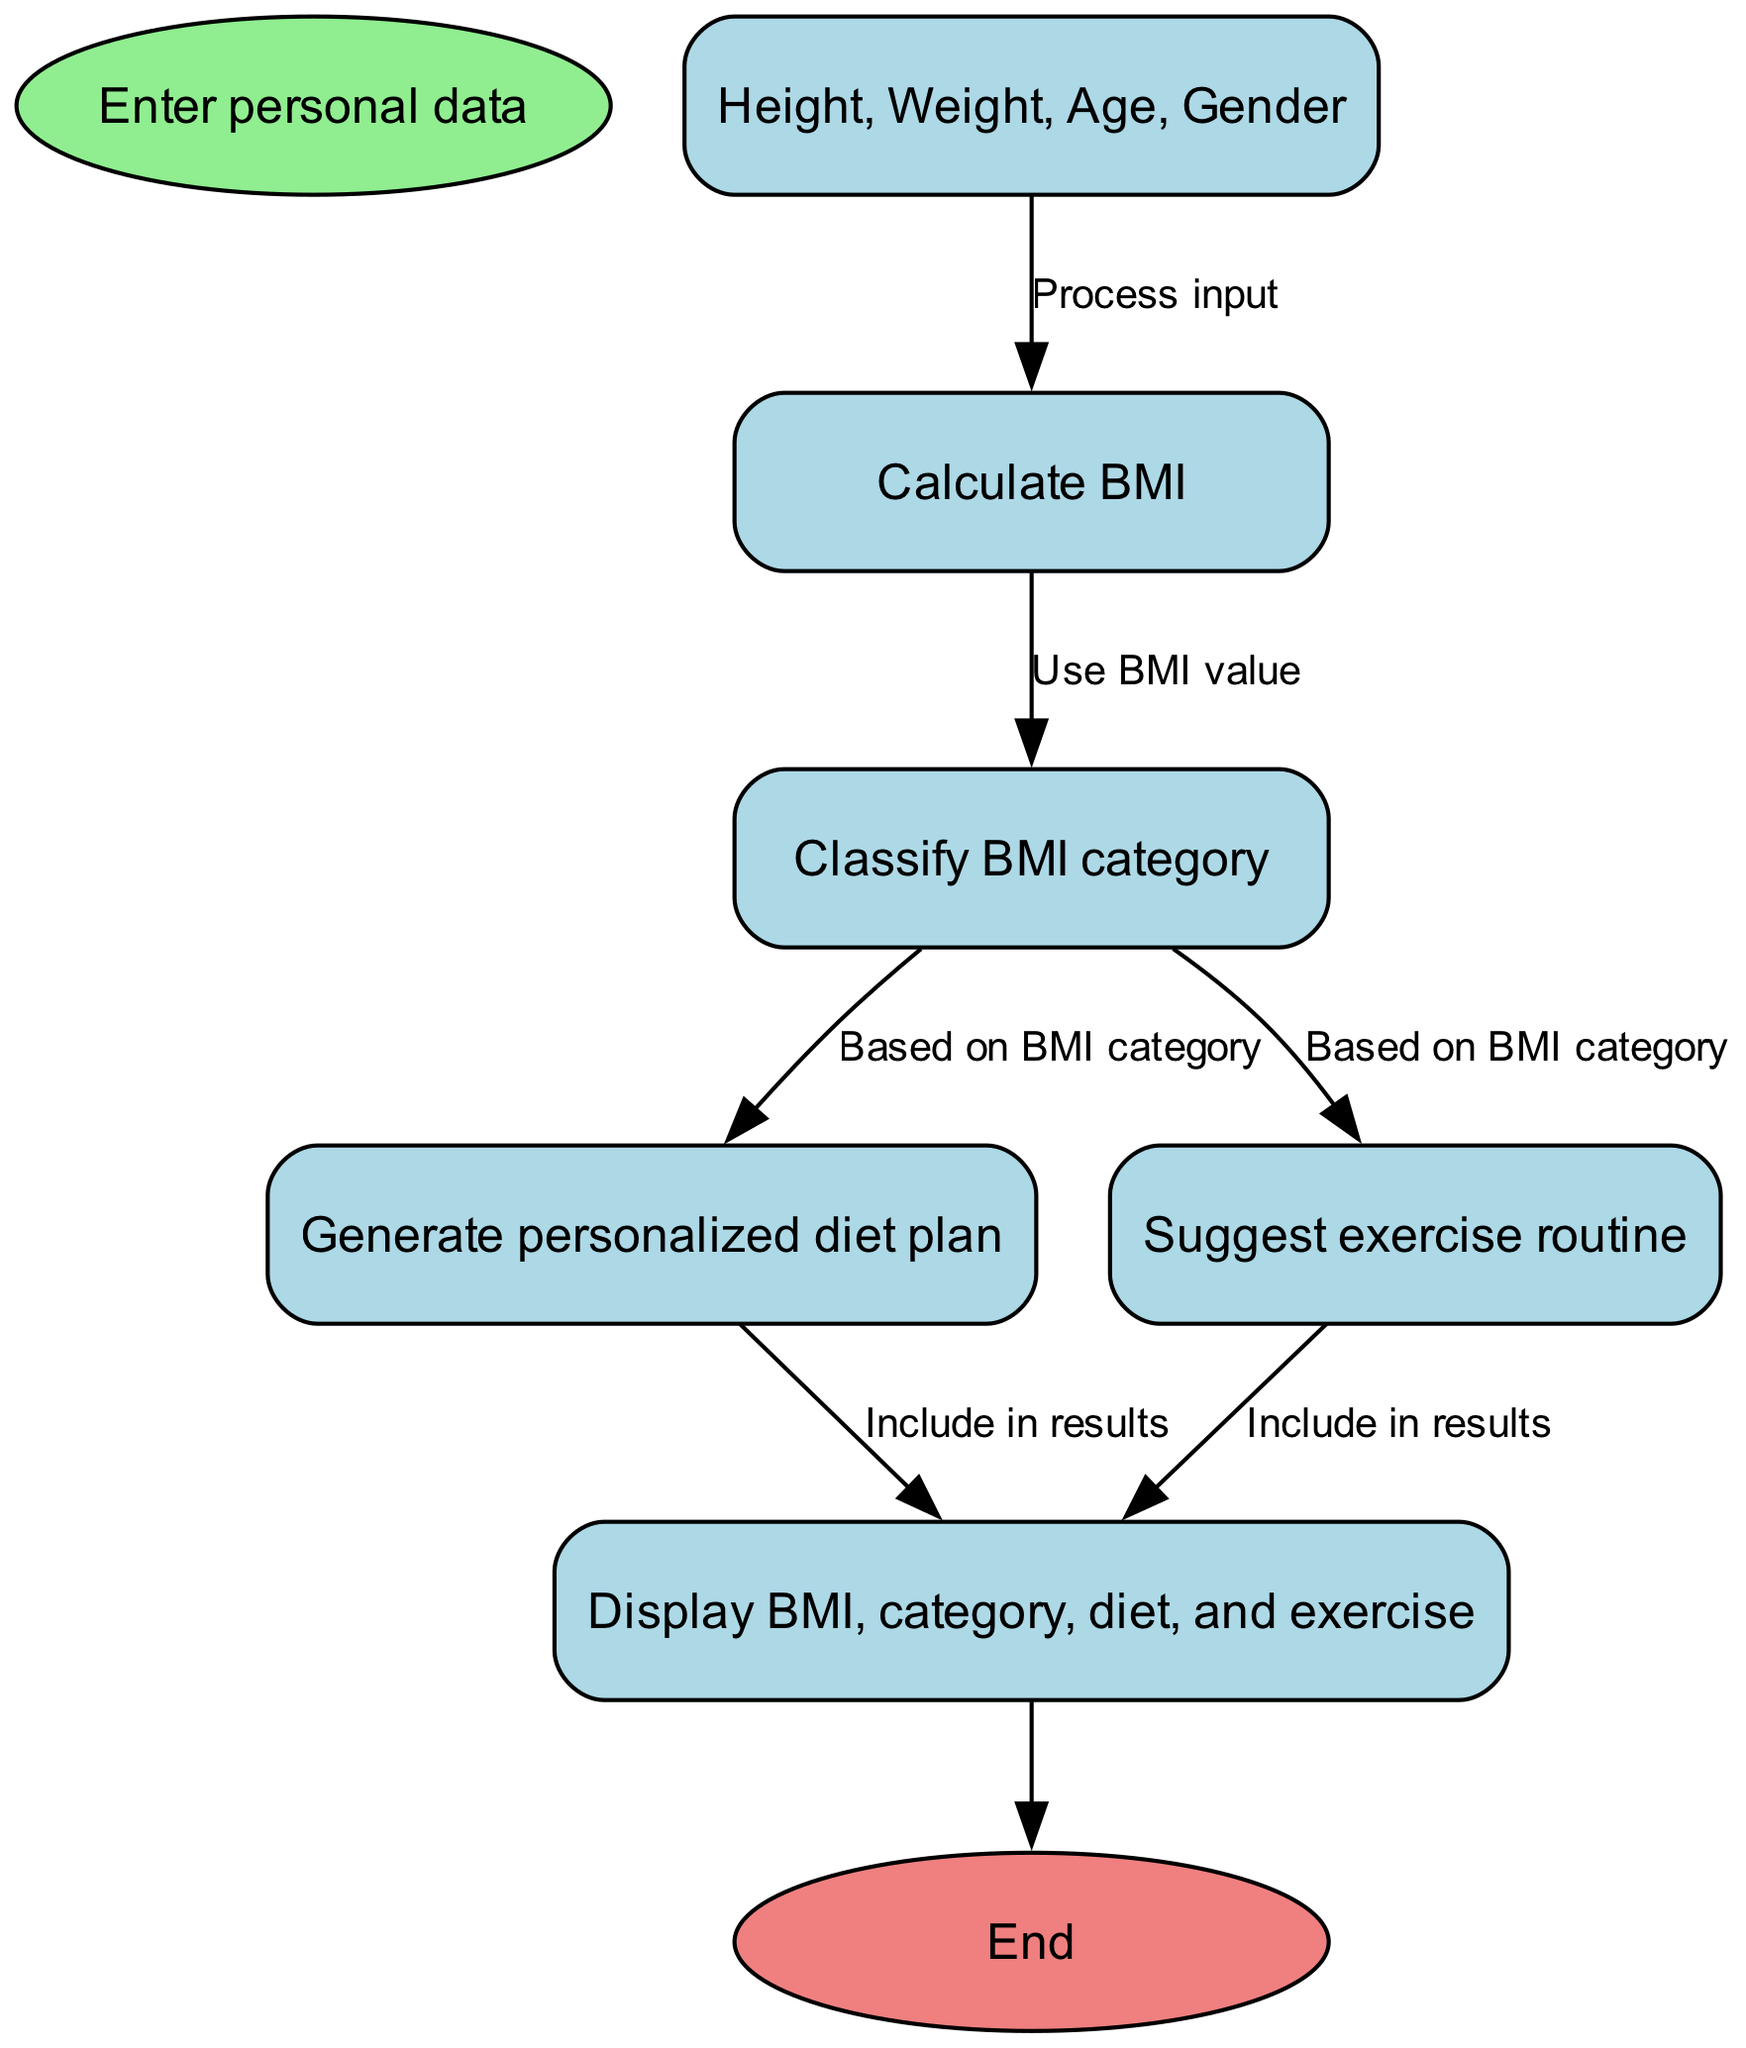What is the initial input required? The initial input required as shown in the diagram is "Enter personal data." This is represented by the first node connected to the start node.
Answer: Enter personal data How many main processing nodes are there? The main processing nodes include calculating BMI, classifying BMI, generating a diet plan, and suggesting an exercise routine. This sums to four nodes within the flow.
Answer: Four What node follows the "Calculate BMI" step? The node that follows "Calculate BMI" in the flow is "Classify BMI category." It directly connects to the calculation node through a directed edge.
Answer: Classify BMI category Which nodes are generated based on BMI category? The nodes that are generated based on the BMI category are "Generate personalized diet plan" and "Suggest exercise routine." Both share the "Classify BMI" node as a predecessor.
Answer: Generate personalized diet plan and Suggest exercise routine What color is the end node? The end node is colored light coral, as indicated in the diagram specifications for the end node.
Answer: Light coral What will be included in the results display? The "Display BMI, category, diet, and exercise" node indicates that the results will include these four components. This is the final output of the entire flow.
Answer: BMI, category, diet, and exercise Which node connects "Generate personalized diet plan" and "Display results"? The node that connects "Generate personalized diet plan" and "Display results" is represented by a directed edge labeled "Include in results," indicating the output flow.
Answer: Include in results What is the relationship between "Calculate BMI" and "Classify BMI category"? The relationship between "Calculate BMI" and "Classify BMI category" is that "Classify BMI category" uses the BMI value obtained from the calculation step. This is shown by the directed edge connecting them.
Answer: Use BMI value What occurs after the initial input? After the initial input, the next step is "Process input," which leads to the calculation of the BMI. This indicates that input is handled before any calculations take place.
Answer: Process input 